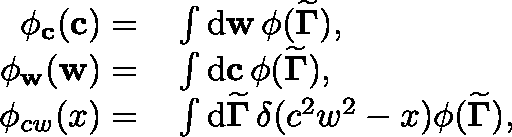<formula> <loc_0><loc_0><loc_500><loc_500>\begin{array} { r l } { \phi _ { c } ( c ) = } & \int d w \, \phi ( { \widetilde { \Gamma } } ) , } \\ { \phi _ { w } ( w ) = } & \int d c \, \phi ( { \widetilde { \Gamma } } ) , } \\ { \phi _ { c w } ( x ) = } & \int d { \widetilde { \Gamma } } \, \delta ( c ^ { 2 } w ^ { 2 } - x ) \phi ( { \widetilde { \Gamma } } ) , } \end{array}</formula> 